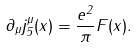<formula> <loc_0><loc_0><loc_500><loc_500>\partial _ { \mu } j _ { 5 } ^ { \mu } ( x ) = \frac { e ^ { 2 } } { \pi } F ( x ) .</formula> 